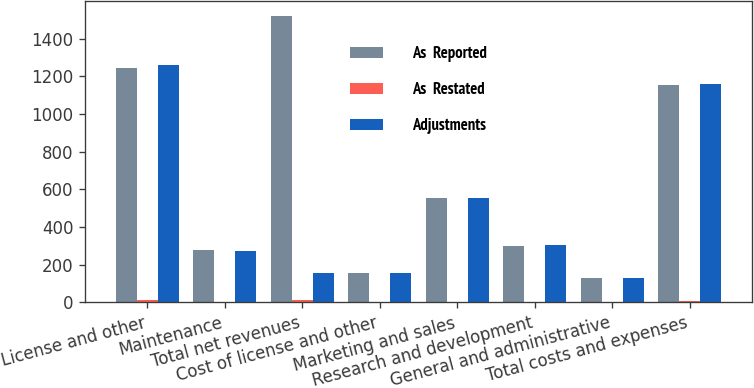<chart> <loc_0><loc_0><loc_500><loc_500><stacked_bar_chart><ecel><fcel>License and other<fcel>Maintenance<fcel>Total net revenues<fcel>Cost of license and other<fcel>Marketing and sales<fcel>Research and development<fcel>General and administrative<fcel>Total costs and expenses<nl><fcel>As  Reported<fcel>1246.7<fcel>276.5<fcel>1523.2<fcel>157.8<fcel>553.8<fcel>301.6<fcel>127.1<fcel>1153.4<nl><fcel>As  Restated<fcel>15.1<fcel>1.1<fcel>14<fcel>0.2<fcel>2.2<fcel>1.6<fcel>1.3<fcel>5.3<nl><fcel>Adjustments<fcel>1261.8<fcel>275.4<fcel>158<fcel>158<fcel>556<fcel>303.2<fcel>128.4<fcel>1158.7<nl></chart> 